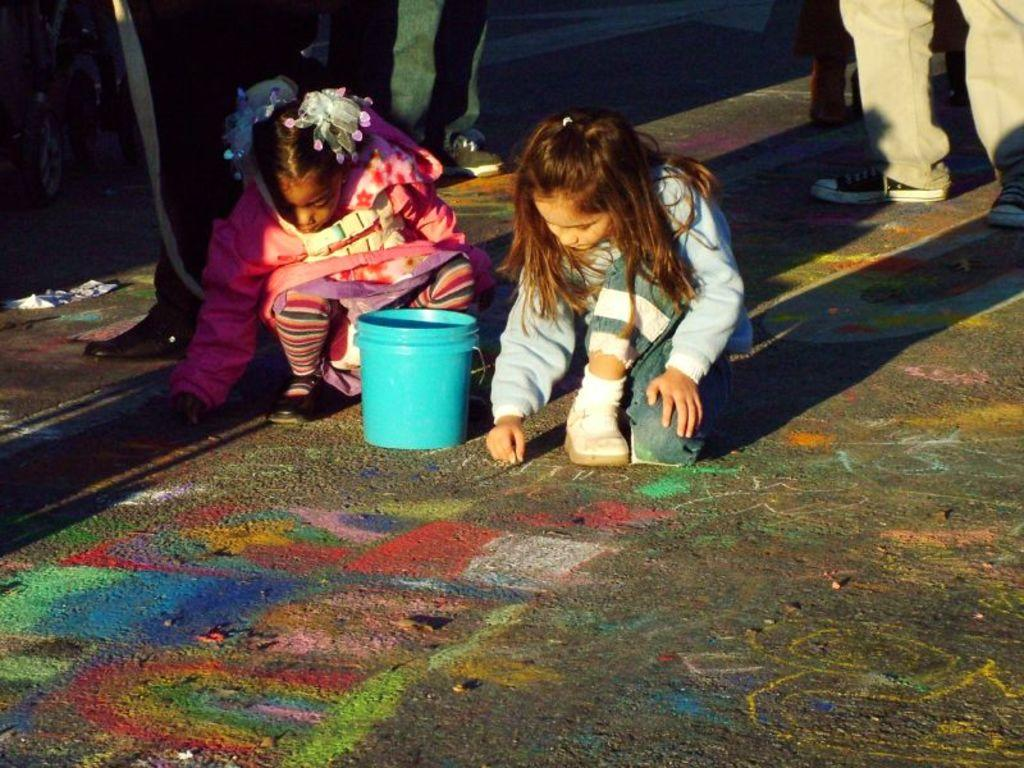How many girls are present in the image? There are two girls in the image. Where are the girls located? The girls are on the road. What object is between the girls? There is a blue color bucket between the girls. Can you describe the background of the image? There are people standing in the background of the image. What type of poison is hidden in the top drawer of the image? There is no mention of a top drawer or poison in the image, so this question cannot be answered. 